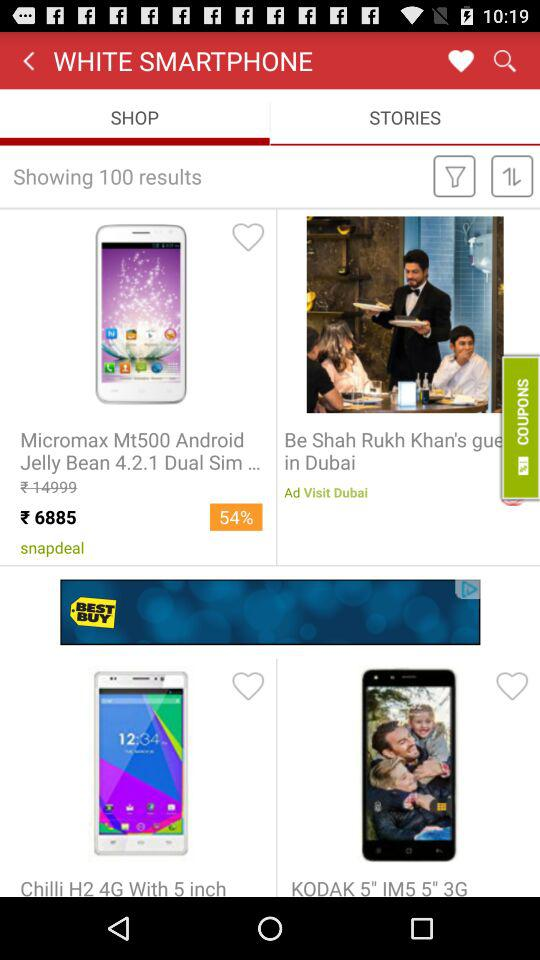How many results are shown?
Answer the question using a single word or phrase. 100 